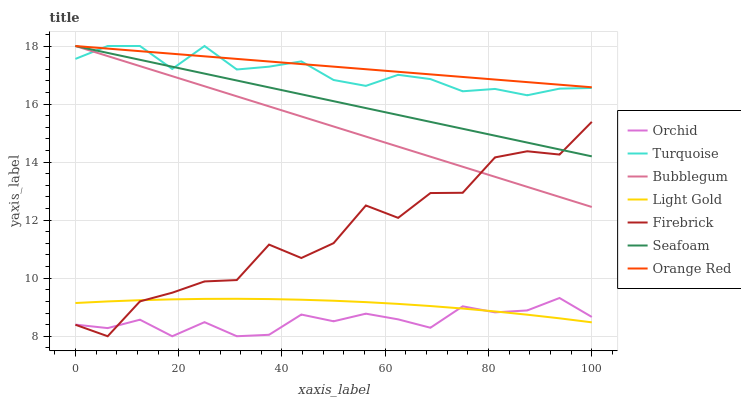Does Orchid have the minimum area under the curve?
Answer yes or no. Yes. Does Orange Red have the maximum area under the curve?
Answer yes or no. Yes. Does Firebrick have the minimum area under the curve?
Answer yes or no. No. Does Firebrick have the maximum area under the curve?
Answer yes or no. No. Is Bubblegum the smoothest?
Answer yes or no. Yes. Is Firebrick the roughest?
Answer yes or no. Yes. Is Seafoam the smoothest?
Answer yes or no. No. Is Seafoam the roughest?
Answer yes or no. No. Does Firebrick have the lowest value?
Answer yes or no. Yes. Does Seafoam have the lowest value?
Answer yes or no. No. Does Orange Red have the highest value?
Answer yes or no. Yes. Does Firebrick have the highest value?
Answer yes or no. No. Is Light Gold less than Turquoise?
Answer yes or no. Yes. Is Seafoam greater than Orchid?
Answer yes or no. Yes. Does Orchid intersect Light Gold?
Answer yes or no. Yes. Is Orchid less than Light Gold?
Answer yes or no. No. Is Orchid greater than Light Gold?
Answer yes or no. No. Does Light Gold intersect Turquoise?
Answer yes or no. No. 